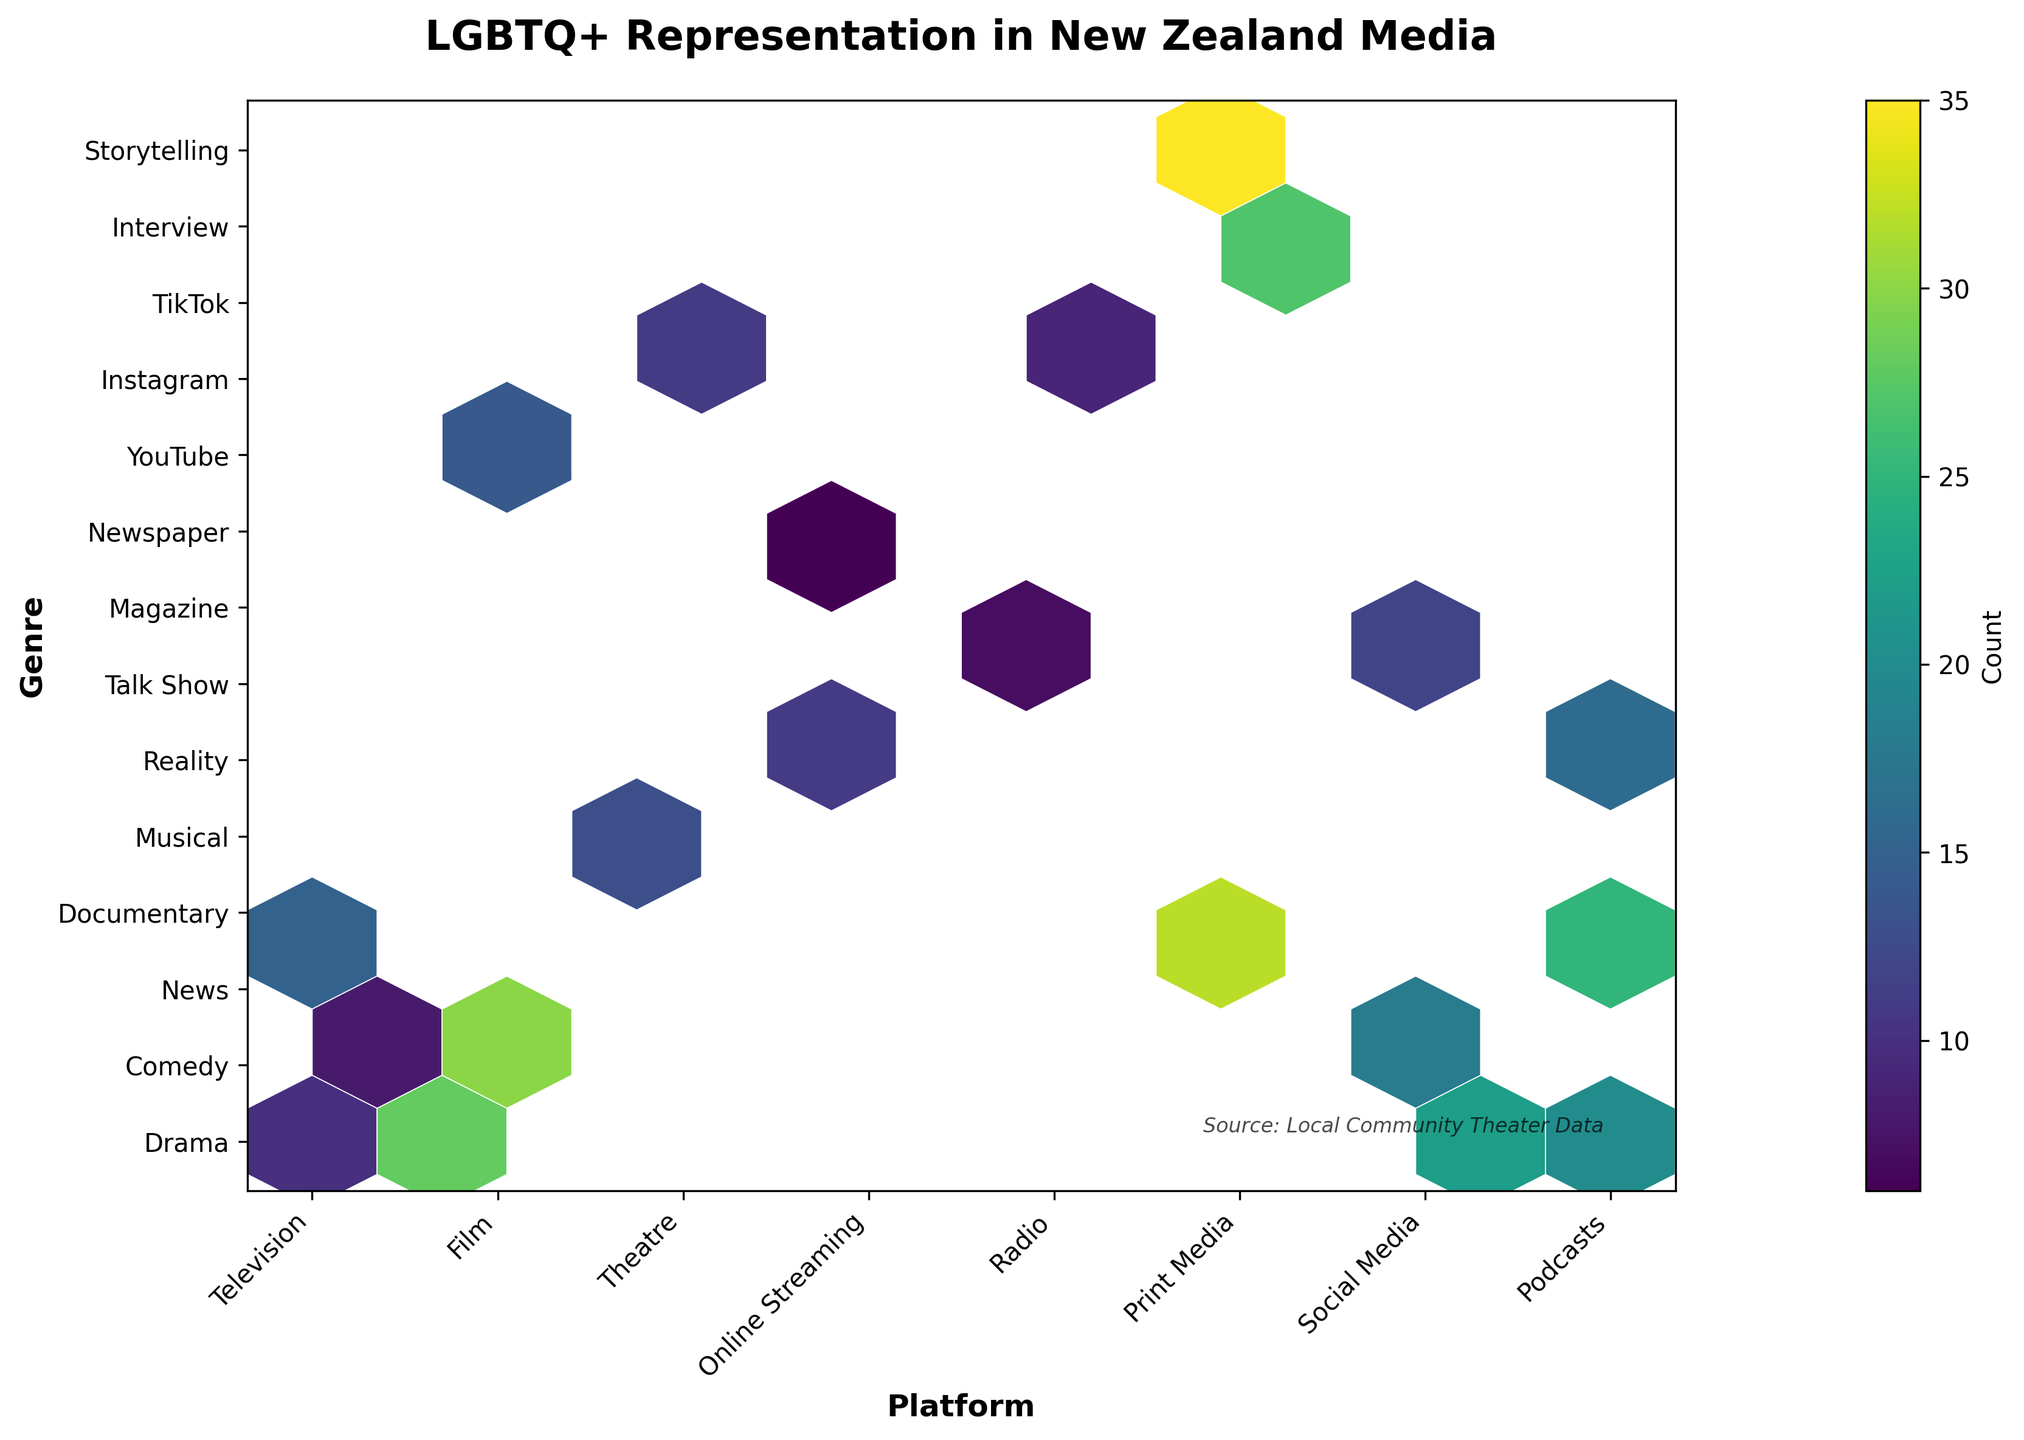What is the title of the plot? The title is displayed at the top of the plot. It reads 'LGBTQ+ Representation in New Zealand Media'.
Answer: LGBTQ+ Representation in New Zealand Media How many different platforms are represented? Look at the x-axis labels, which represent the platforms. Count them. The platforms are: Television, Film, Theatre, Online Streaming, Radio, Print Media, Social Media, and Podcasts.
Answer: 8 Which genre has the highest LGBTQ+ representation on Social Media? Look at the hexagons in the 'Social Media' column on the x-axis and check which one has the darkest color, representing the highest count. 'YouTube' has the highest representation.
Answer: YouTube What is the sum of LGBTQ+ representations in the Drama genre across all platforms? Identify the hexagons across the 'Drama' row on the y-axis and sum up the counts. The counts are 18 (Television) + 15 (Film) + 25 (Theatre) + 30 (Online Streaming) = 88.
Answer: 88 Which platform has the least variety of genres? Look at each platform's column on the x-axis and see which one covers the fewest genres on the y-axis. 'Radio' covers only two genres: 'Talk Show' and 'News'.
Answer: Radio Compare the LGBTQ+ representation in Comedy on Television and Online Streaming. Which one is higher? Find the hexagons representing Comedy in both Television and Online Streaming columns and compare their colors or counts. Online Streaming's count (28) is higher than Television's count (22).
Answer: Online Streaming Is the LGBTQ+ representation in Theatre Drama higher than in Film Drama? Compare the counts of these specific hexagons. Theatre Drama's count is 25, whereas Film Drama's count is 15. Theatre Drama is higher.
Answer: Yes What's the average LGBTQ+ representation count for the Comedy genre across all platforms? Identify and sum the counts for Comedy in all platforms, then divide by the number of platforms. The counts are 22 (Television) + 10 (Film) + 20 (Theatre) + 28 (Online Streaming) = 80. Divide 80 by 4 platforms = 20.
Answer: 20 How does the representation in Podcasts for the Interview genre compare to Print Media for the Magazine genre? Compare the counts for these specific hexagons. Podcasts for Interview has a count of 13, and Print Media for Magazine has a count of 11. Podcasts for Interview is higher.
Answer: Podcasts for Interview 